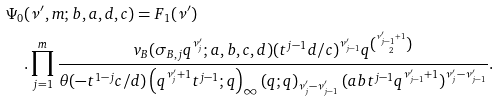Convert formula to latex. <formula><loc_0><loc_0><loc_500><loc_500>\Psi _ { 0 } & ( \nu ^ { \prime } , m ; b , a , d , c ) = F _ { 1 } ( \nu ^ { \prime } ) \\ & . \prod _ { j = 1 } ^ { m } \frac { v _ { B } ( \sigma _ { B , j } q ^ { \nu _ { j } ^ { \prime } } ; a , b , c , d ) ( t ^ { j - 1 } d / c ) ^ { \nu _ { j - 1 } ^ { \prime } } q ^ { \binom { \nu _ { j - 1 } ^ { \prime } + 1 } { 2 } } } { \theta ( - t ^ { 1 - j } c / d ) \left ( q ^ { \nu _ { j } ^ { \prime } + 1 } t ^ { j - 1 } ; q \right ) _ { \infty } \left ( q ; q \right ) _ { \nu _ { j } ^ { \prime } - \nu _ { j - 1 } ^ { \prime } } ( a b t ^ { j - 1 } q ^ { \nu _ { j - 1 } ^ { \prime } + 1 } ) ^ { \nu _ { j } ^ { \prime } - \nu _ { j - 1 } ^ { \prime } } } . \\</formula> 